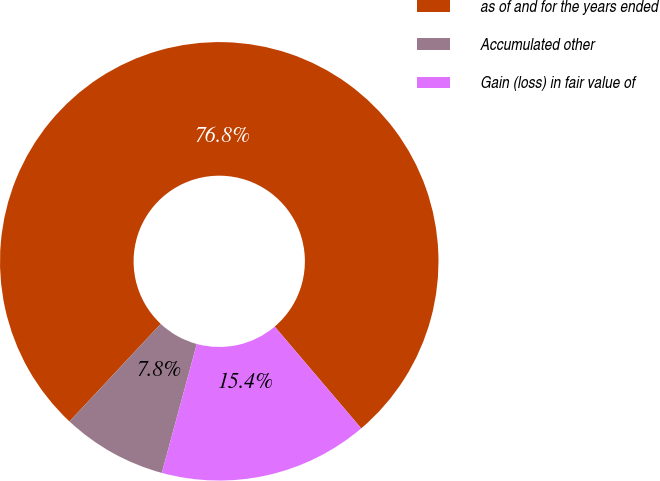Convert chart. <chart><loc_0><loc_0><loc_500><loc_500><pie_chart><fcel>as of and for the years ended<fcel>Accumulated other<fcel>Gain (loss) in fair value of<nl><fcel>76.82%<fcel>7.75%<fcel>15.43%<nl></chart> 